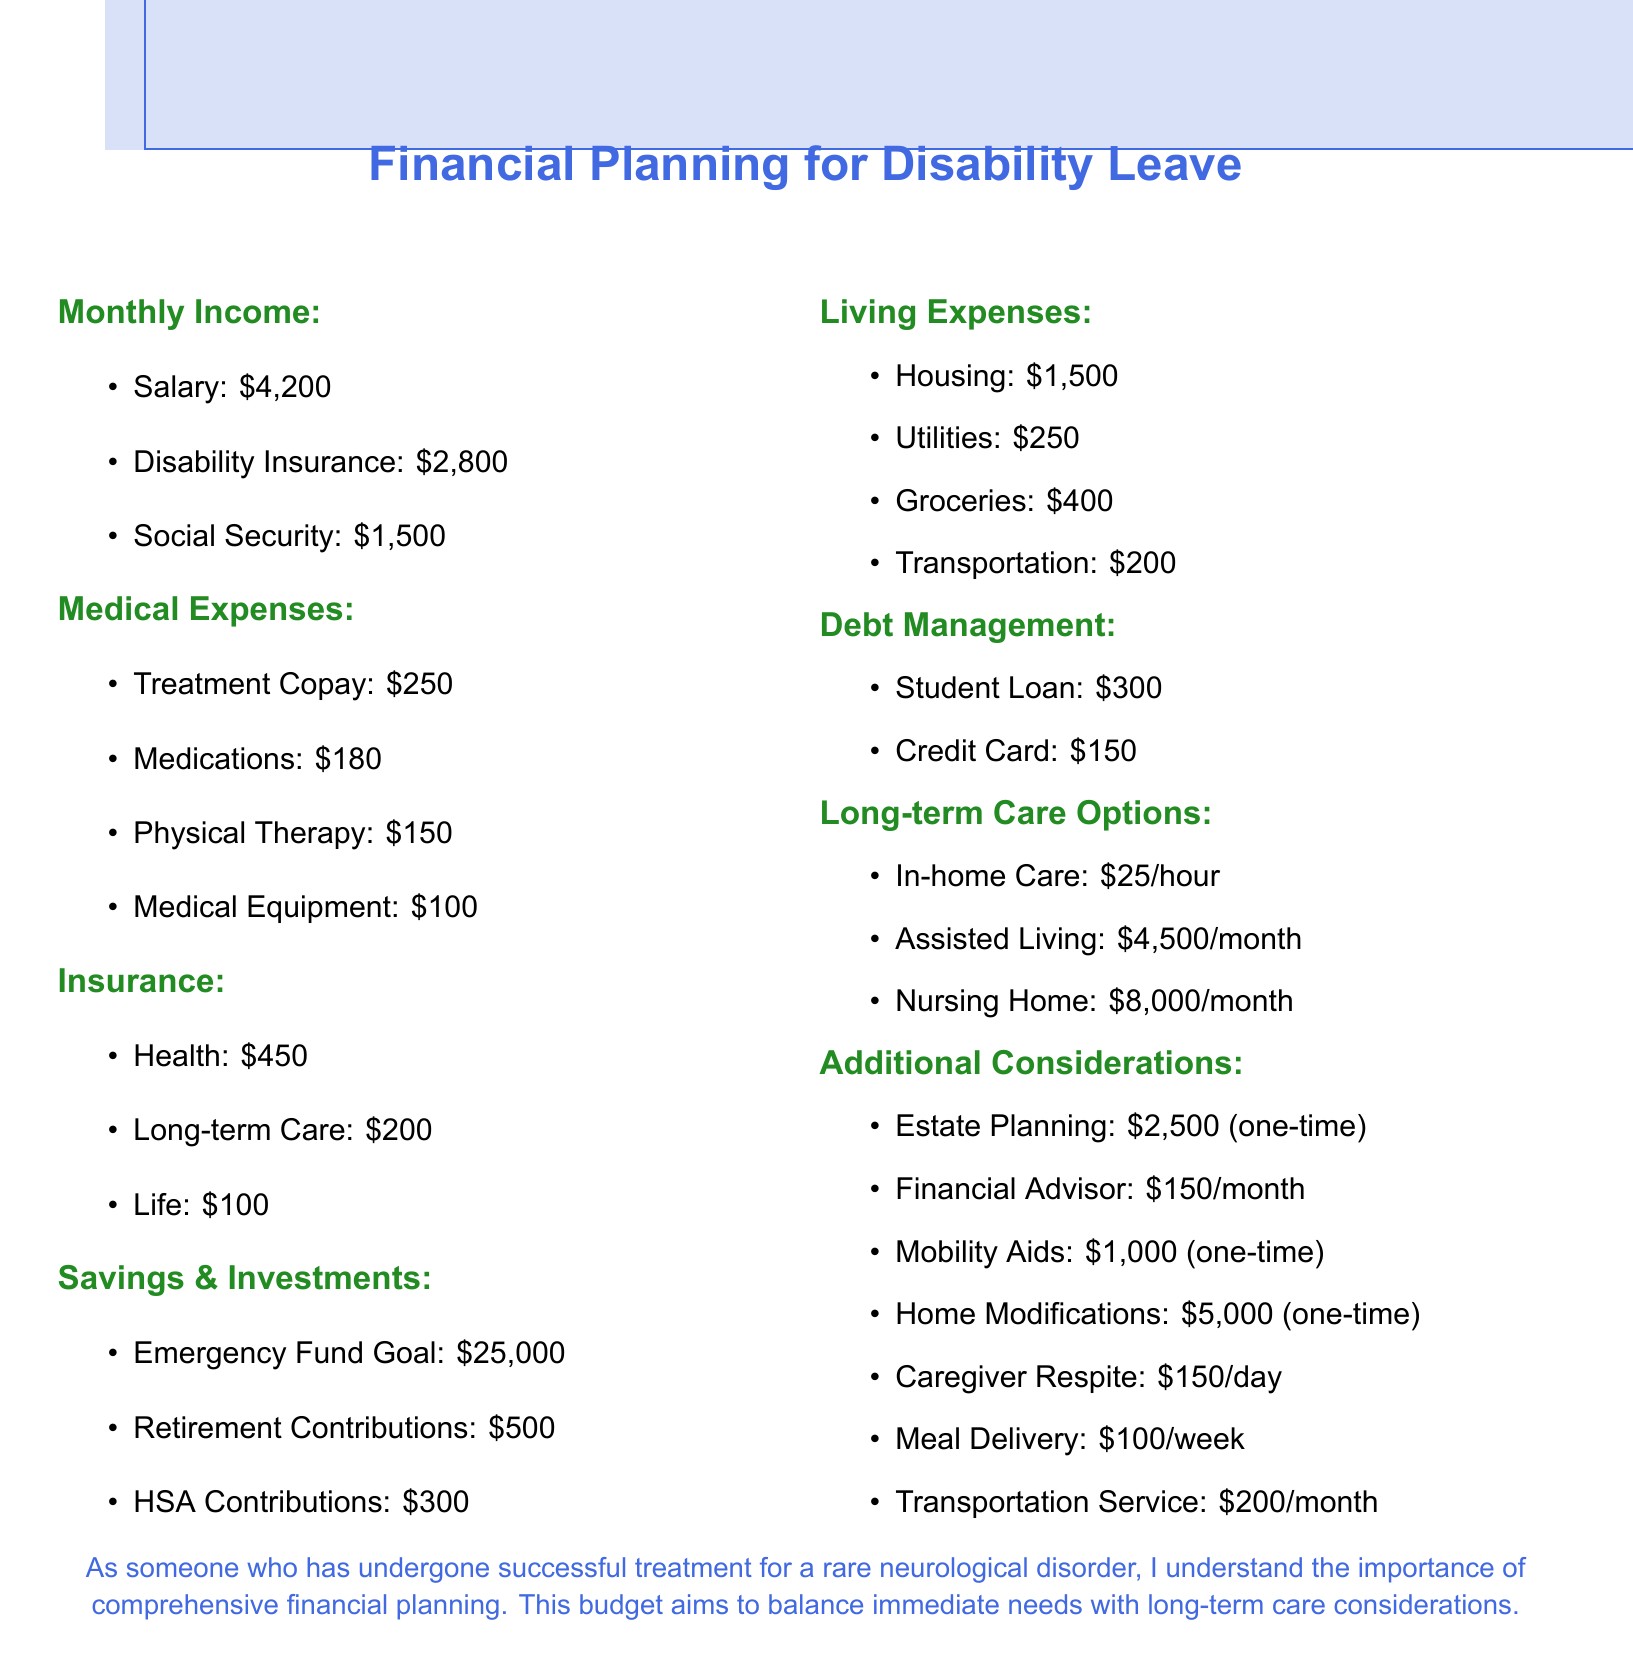What is the total monthly income? The total monthly income is calculated by adding Salary, Disability Insurance, and Social Security: $4,200 + $2,800 + $1,500 = $8,500.
Answer: $8,500 What is the total for medical expenses? The total medical expenses are calculated by adding all relevant costs: $250 + $180 + $150 + $100 = $680.
Answer: $680 What is the cost of in-home care? In-home care is listed as $25/hour in the document.
Answer: $25/hour How much is allocated for retirement contributions? The document specifies that retirement contributions are $500.
Answer: $500 What is the emergency fund goal? The emergency fund goal is stated as $25,000 in the document.
Answer: $25,000 What are the total living expenses? Total living expenses are calculated as: $1,500 + $250 + $400 + $200 = $2,350.
Answer: $2,350 What is the cost of assisted living? The cost of assisted living is given as $4,500/month in the document.
Answer: $4,500/month What is one of the additional considerations listed? The document lists several additional considerations, one being Estate Planning.
Answer: Estate Planning How much is the cost of meal delivery per week? The document specifies that meal delivery costs $100/week.
Answer: $100/week What is the total cost of the one-time expenses? The total of one-time expenses is calculated as: $2,500 + $1,000 + $5,000 = $8,500.
Answer: $8,500 